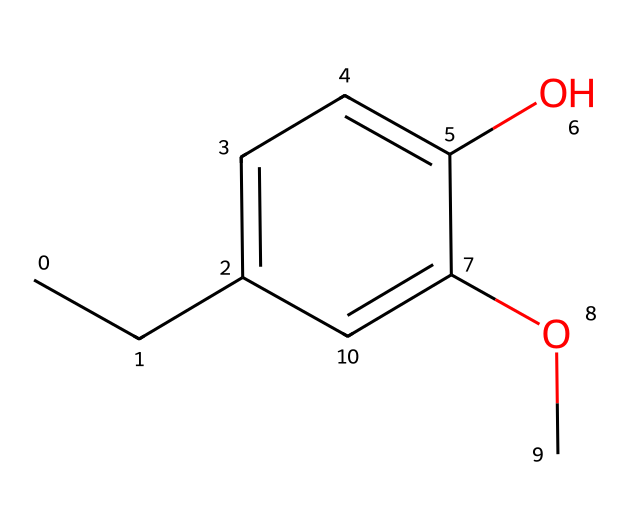What is the molecular formula of eugenol? The SMILES representation can be used to determine the molecular formula by counting the atoms. The structure contains 10 carbon (C) atoms, 12 hydrogen (H) atoms, and 2 oxygen (O) atoms, resulting in the molecular formula C10H12O2.
Answer: C10H12O2 How many hydroxyl (OH) groups are present in eugenol? A hydroxyl group is indicated by the presence of an oxygen atom bonded to a hydrogen atom. In the SMILES, there is one (-OH) group, marking eugenol as a phenolic compound.
Answer: 1 What type of functional group is present in eugenol? The presence of the hydroxyl (-OH) group indicates that eugenol contains a phenol functional group, a characteristic of phenolic compounds.
Answer: phenol Why is eugenol considered a phenolic compound? Eugenol has a hydroxyl group (-OH) directly attached to a benzene ring, fulfilling the criteria for a phenol, which consists of an aromatic compound containing a hydroxyl group.
Answer: hydroxyl group attached to benzene What is the significance of the methoxy group in eugenol? The methoxy group (-OCH3) modifies the properties of eugenol, affecting its reactivity and making it a useful compound in various applications, including religious ceremonies.
Answer: modifies properties How many double bonds are in the eugenol structure? The structure can be analyzed based on the presence of double bonds in the aromatic ring and the double bond between the carbon atoms. There are 2 double bonds present in the carbon chain and ring structure.
Answer: 2 What type of chemical bond connects the oxygen atom in the hydroxyl group to the carbon atom? The bond between the hydrogen atom and the oxygen in the hydroxyl group is a single covalent bond, which is characteristic of hydroxyl functional groups in phenols.
Answer: single covalent bond 